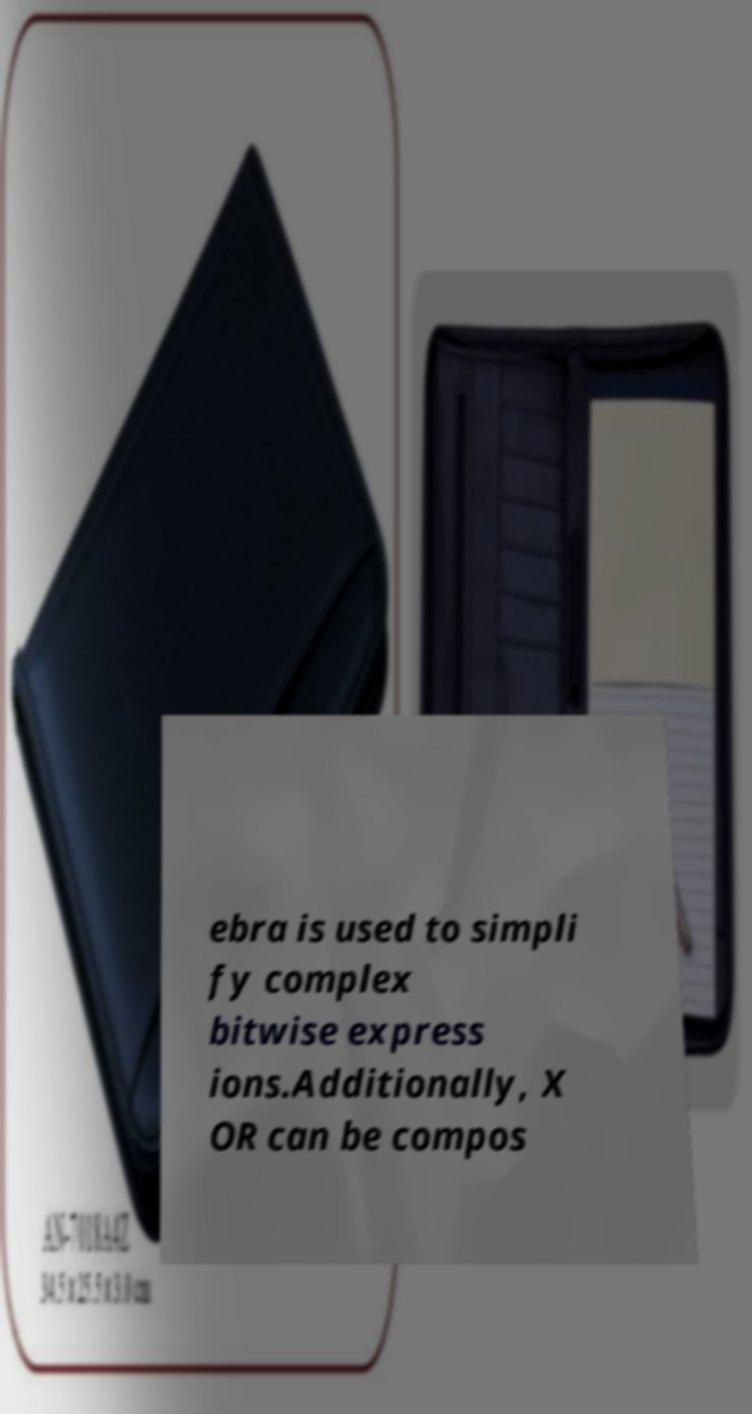What messages or text are displayed in this image? I need them in a readable, typed format. ebra is used to simpli fy complex bitwise express ions.Additionally, X OR can be compos 